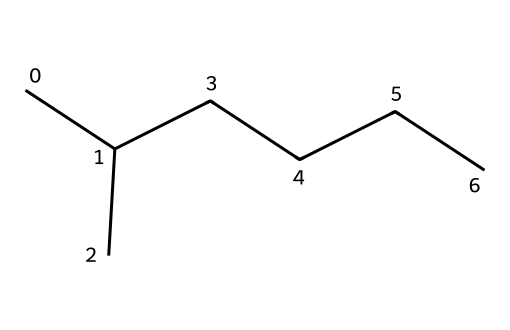What is the molecular formula represented by the SMILES? The SMILES notation provided indicates a structure with six carbon (C) atoms and fourteen hydrogen (H) atoms, leading to the molecular formula C6H14.
Answer: C6H14 How many carbon atoms are in the structure? By interpreting the SMILES notation, we count six distinct carbon atoms in the chain, which is evident from the arrangement and branching.
Answer: 6 What type of molecule is defined by this SMILES representation? The presence of only carbon and hydrogen atoms without functional groups indicates that this is an alkane, specifically a branched alkane based on the structure.
Answer: alkane Is this chemical typically considered safe for children's toys? Alkanes, being saturated hydrocarbons, are generally regarded as non-toxic and safe for various applications, including children's toys, as they do not release harmful chemicals.
Answer: yes Which functional characteristic makes this molecule suitable for plastic toy production? The fact that this compound is a saturated hydrocarbon allows it to have flexible properties and chemical stability, making it useful for creating durable plastic materials.
Answer: flexibility How many hydrogen atoms are attached to the last carbon in the chain? In a branched alkane like this, the terminal carbon (the end of the chain) typically has three hydrogen atoms attached, as it is not connected to other carbon atoms at that position.
Answer: 3 